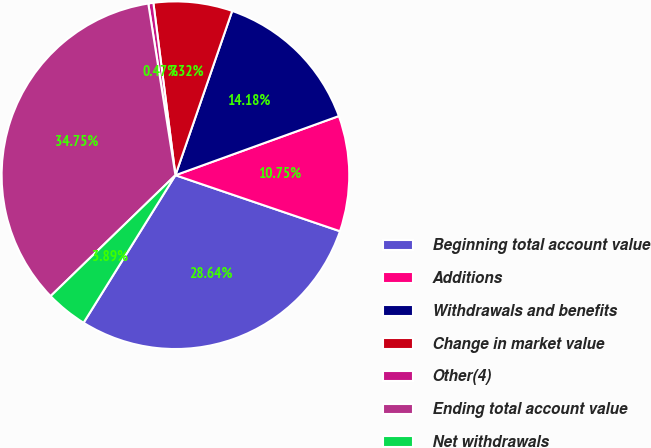Convert chart to OTSL. <chart><loc_0><loc_0><loc_500><loc_500><pie_chart><fcel>Beginning total account value<fcel>Additions<fcel>Withdrawals and benefits<fcel>Change in market value<fcel>Other(4)<fcel>Ending total account value<fcel>Net withdrawals<nl><fcel>28.64%<fcel>10.75%<fcel>14.18%<fcel>7.32%<fcel>0.47%<fcel>34.75%<fcel>3.89%<nl></chart> 